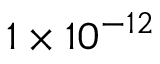<formula> <loc_0><loc_0><loc_500><loc_500>1 \times 1 0 ^ { - 1 2 }</formula> 